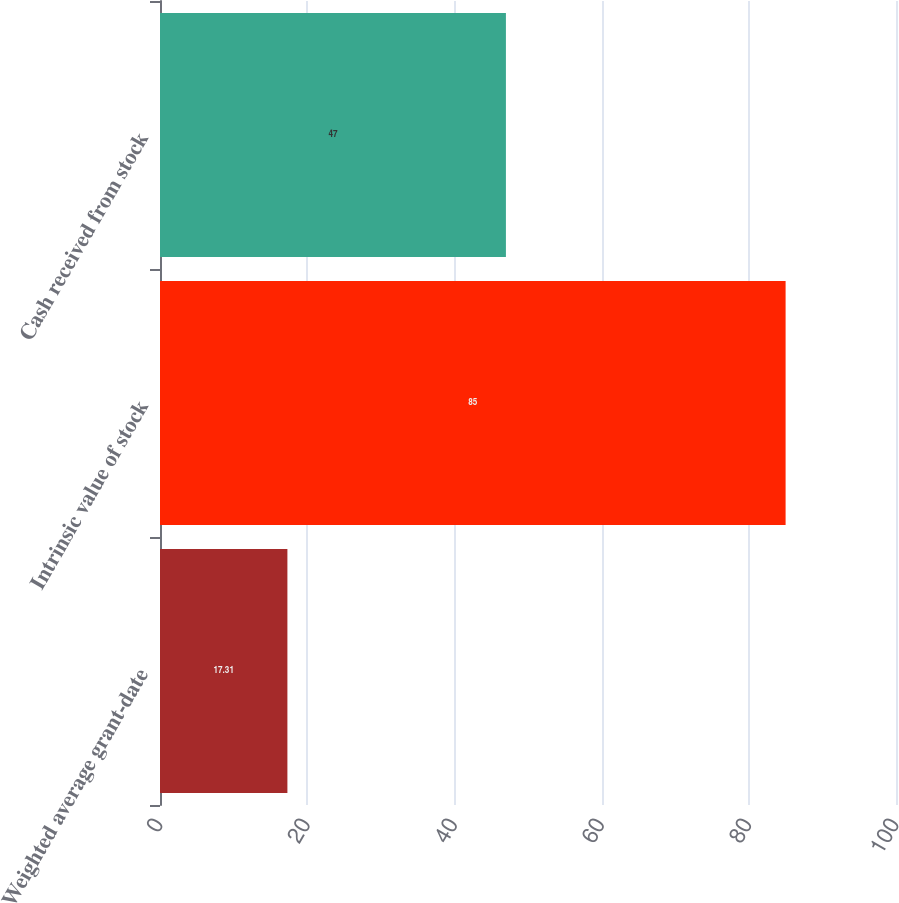Convert chart. <chart><loc_0><loc_0><loc_500><loc_500><bar_chart><fcel>Weighted average grant-date<fcel>Intrinsic value of stock<fcel>Cash received from stock<nl><fcel>17.31<fcel>85<fcel>47<nl></chart> 